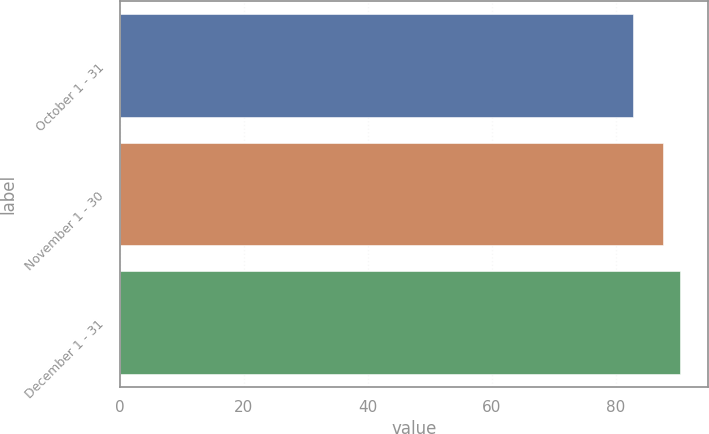Convert chart. <chart><loc_0><loc_0><loc_500><loc_500><bar_chart><fcel>October 1 - 31<fcel>November 1 - 30<fcel>December 1 - 31<nl><fcel>82.77<fcel>87.63<fcel>90.38<nl></chart> 